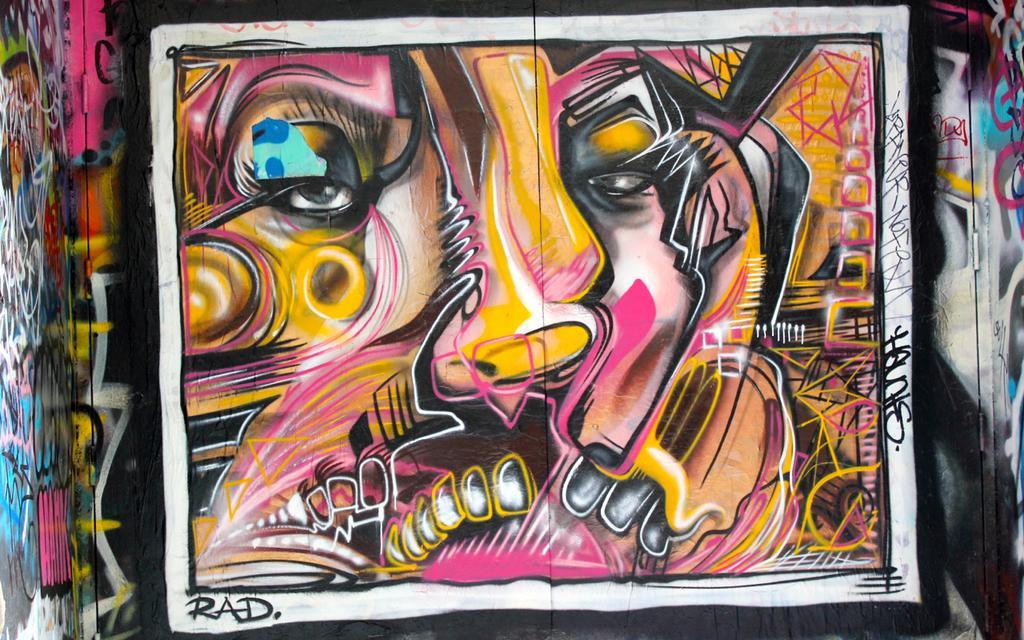Please provide a concise description of this image. In this picture we can see graffiti on the wall. 